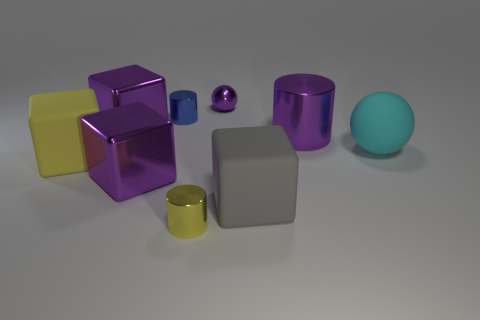There is a large cylinder that is the same color as the small shiny sphere; what is its material?
Offer a very short reply. Metal. What is the material of the yellow object that is the same shape as the gray matte thing?
Your answer should be compact. Rubber. There is a tiny sphere that is to the right of the big yellow rubber block; is it the same color as the large metallic block behind the cyan thing?
Give a very brief answer. Yes. Is the color of the block behind the cyan ball the same as the large cylinder?
Provide a succinct answer. Yes. There is a sphere that is the same color as the big cylinder; what is its size?
Provide a short and direct response. Small. Are there any big blocks of the same color as the large cylinder?
Ensure brevity in your answer.  Yes. What color is the matte block that is the same size as the gray thing?
Offer a terse response. Yellow. Are there any shiny cylinders in front of the large metallic object that is to the right of the tiny purple sphere?
Your answer should be very brief. Yes. What is the yellow thing behind the tiny yellow object made of?
Offer a very short reply. Rubber. Is the material of the ball that is right of the large purple metallic cylinder the same as the yellow object that is on the right side of the big yellow rubber object?
Offer a terse response. No. 